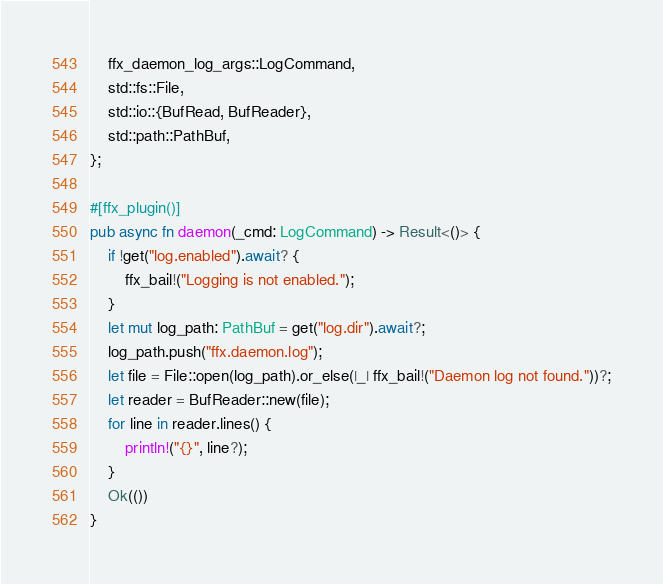<code> <loc_0><loc_0><loc_500><loc_500><_Rust_>    ffx_daemon_log_args::LogCommand,
    std::fs::File,
    std::io::{BufRead, BufReader},
    std::path::PathBuf,
};

#[ffx_plugin()]
pub async fn daemon(_cmd: LogCommand) -> Result<()> {
    if !get("log.enabled").await? {
        ffx_bail!("Logging is not enabled.");
    }
    let mut log_path: PathBuf = get("log.dir").await?;
    log_path.push("ffx.daemon.log");
    let file = File::open(log_path).or_else(|_| ffx_bail!("Daemon log not found."))?;
    let reader = BufReader::new(file);
    for line in reader.lines() {
        println!("{}", line?);
    }
    Ok(())
}
</code> 